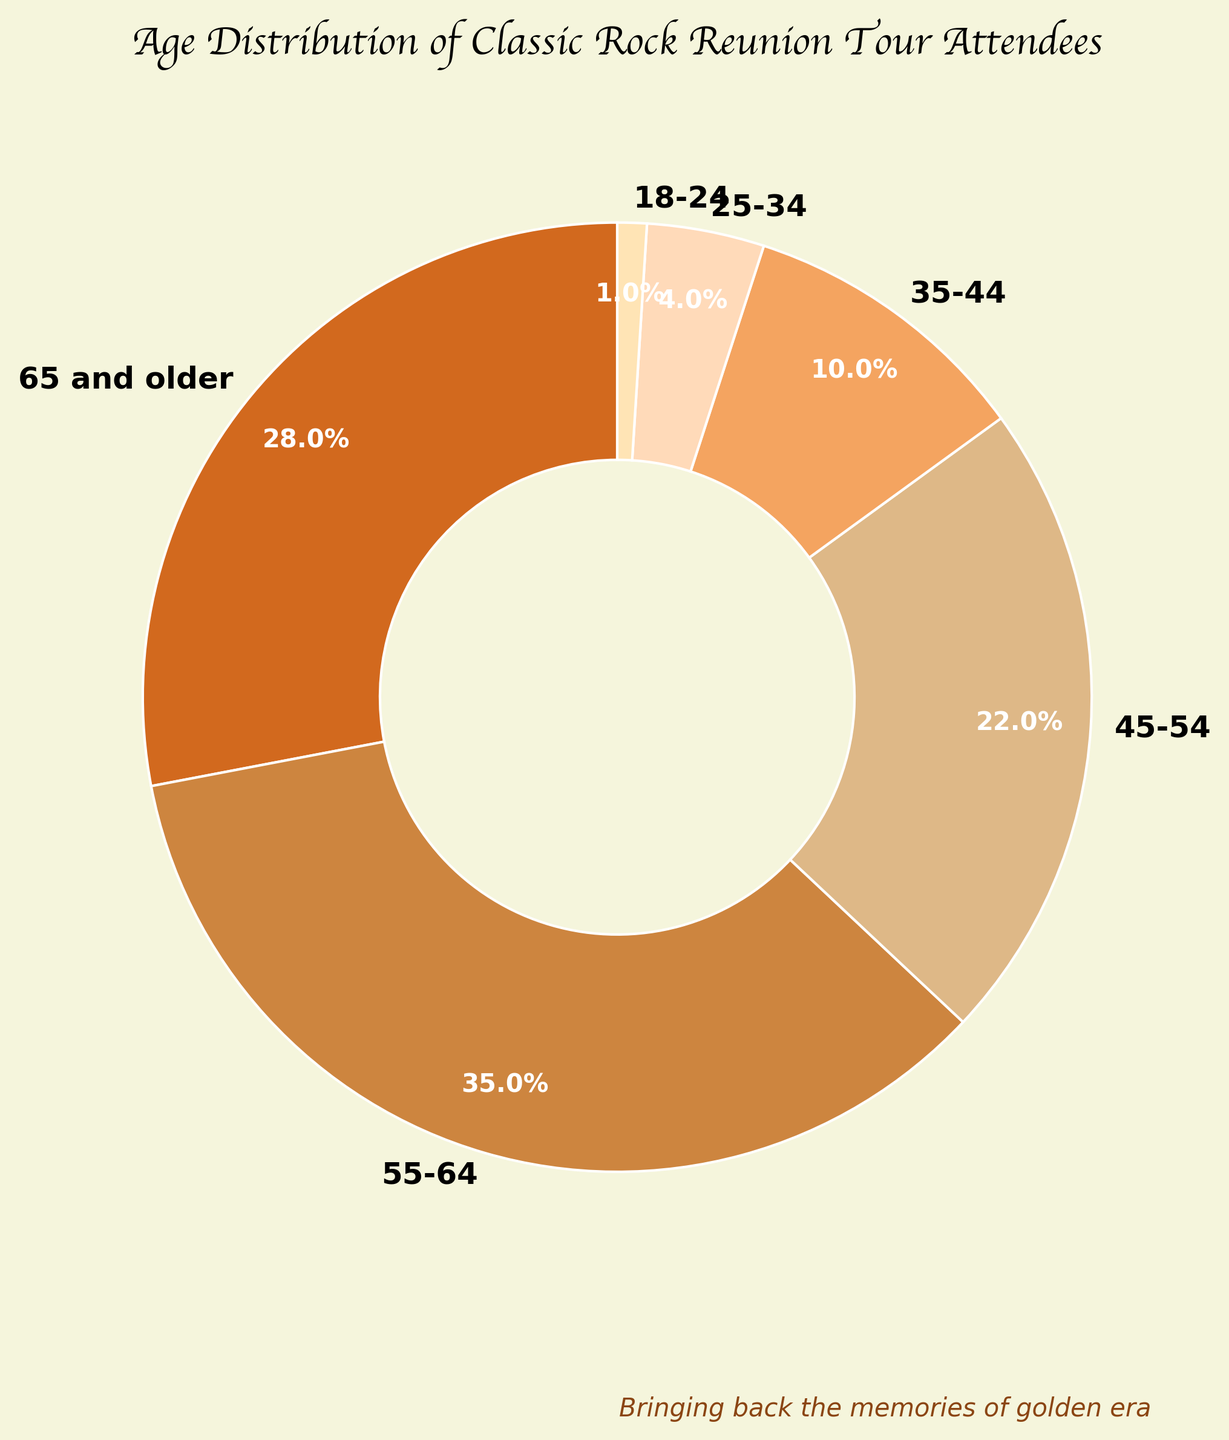Which age group has the highest percentage of attendees for classic rock reunion tours? By looking at the pie chart, identify the segment with the largest portion.
Answer: 55-64 How much more percentage do attendees aged 55-64 make up than those aged 45-54? Find the difference between the percentages for the 55-64 age group and the 45-54 age group: 35% - 22% = 13%.
Answer: 13% What is the total percentage of attendees aged 35-44 and 45-54 combined? Sum the percentages of the 35-44 and 45-54 age groups: 10% + 22% = 32%.
Answer: 32% Which age group makes up the smallest percentage of attendees? Locate the smallest segment in the pie chart.
Answer: 18-24 Is the percentage of attendees aged 65 and older greater than those aged 45-54 and 35-44 combined? Compare the 65 and older percentage (28%) with the combined percentage of 45-54 and 35-44 (22% + 10% = 32%). Since 28% is less than 32%, the answer is no.
Answer: No What percentage of attendees are aged 55 and older? Sum the percentages of the 55-64 (35%) and 65 and older (28%) age groups: 35% + 28% = 63%.
Answer: 63% Which age group has a percentage closest to 10%? Look at the segments and identify the one closest to 10%.
Answer: 35-44 By how many percentage points do the attendees aged 18-24 differ from those aged 25-34? Find the difference between 18-24 (1%) and 25-34 (4%): 4% - 1% = 3%.
Answer: 3% What is the average percentage of the age groups under 35 years of age? Calculate the average of the percentages for 18-24 and 25-34: (1% + 4%) / 2 = 2.5%.
Answer: 2.5% 